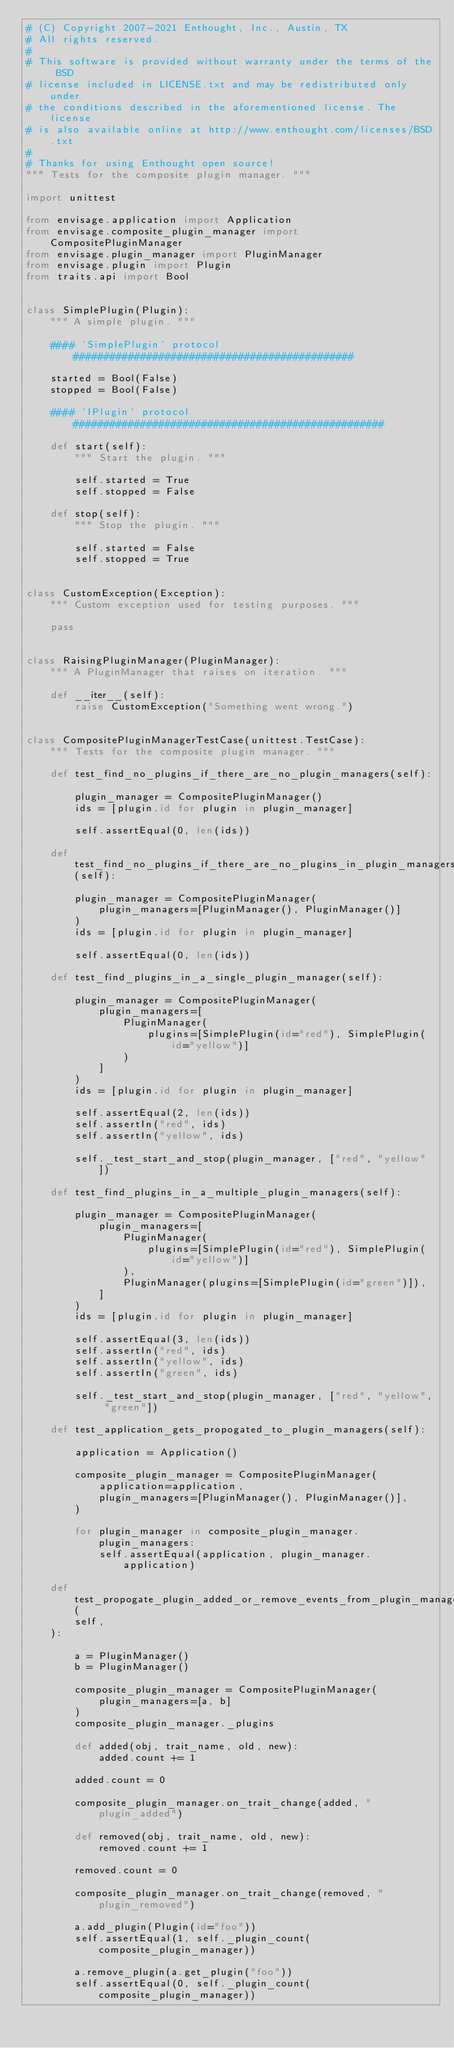<code> <loc_0><loc_0><loc_500><loc_500><_Python_># (C) Copyright 2007-2021 Enthought, Inc., Austin, TX
# All rights reserved.
#
# This software is provided without warranty under the terms of the BSD
# license included in LICENSE.txt and may be redistributed only under
# the conditions described in the aforementioned license. The license
# is also available online at http://www.enthought.com/licenses/BSD.txt
#
# Thanks for using Enthought open source!
""" Tests for the composite plugin manager. """

import unittest

from envisage.application import Application
from envisage.composite_plugin_manager import CompositePluginManager
from envisage.plugin_manager import PluginManager
from envisage.plugin import Plugin
from traits.api import Bool


class SimplePlugin(Plugin):
    """ A simple plugin. """

    #### 'SimplePlugin' protocol ##############################################

    started = Bool(False)
    stopped = Bool(False)

    #### 'IPlugin' protocol ###################################################

    def start(self):
        """ Start the plugin. """

        self.started = True
        self.stopped = False

    def stop(self):
        """ Stop the plugin. """

        self.started = False
        self.stopped = True


class CustomException(Exception):
    """ Custom exception used for testing purposes. """

    pass


class RaisingPluginManager(PluginManager):
    """ A PluginManager that raises on iteration. """

    def __iter__(self):
        raise CustomException("Something went wrong.")


class CompositePluginManagerTestCase(unittest.TestCase):
    """ Tests for the composite plugin manager. """

    def test_find_no_plugins_if_there_are_no_plugin_managers(self):

        plugin_manager = CompositePluginManager()
        ids = [plugin.id for plugin in plugin_manager]

        self.assertEqual(0, len(ids))

    def test_find_no_plugins_if_there_are_no_plugins_in_plugin_managers(self):

        plugin_manager = CompositePluginManager(
            plugin_managers=[PluginManager(), PluginManager()]
        )
        ids = [plugin.id for plugin in plugin_manager]

        self.assertEqual(0, len(ids))

    def test_find_plugins_in_a_single_plugin_manager(self):

        plugin_manager = CompositePluginManager(
            plugin_managers=[
                PluginManager(
                    plugins=[SimplePlugin(id="red"), SimplePlugin(id="yellow")]
                )
            ]
        )
        ids = [plugin.id for plugin in plugin_manager]

        self.assertEqual(2, len(ids))
        self.assertIn("red", ids)
        self.assertIn("yellow", ids)

        self._test_start_and_stop(plugin_manager, ["red", "yellow"])

    def test_find_plugins_in_a_multiple_plugin_managers(self):

        plugin_manager = CompositePluginManager(
            plugin_managers=[
                PluginManager(
                    plugins=[SimplePlugin(id="red"), SimplePlugin(id="yellow")]
                ),
                PluginManager(plugins=[SimplePlugin(id="green")]),
            ]
        )
        ids = [plugin.id for plugin in plugin_manager]

        self.assertEqual(3, len(ids))
        self.assertIn("red", ids)
        self.assertIn("yellow", ids)
        self.assertIn("green", ids)

        self._test_start_and_stop(plugin_manager, ["red", "yellow", "green"])

    def test_application_gets_propogated_to_plugin_managers(self):

        application = Application()

        composite_plugin_manager = CompositePluginManager(
            application=application,
            plugin_managers=[PluginManager(), PluginManager()],
        )

        for plugin_manager in composite_plugin_manager.plugin_managers:
            self.assertEqual(application, plugin_manager.application)

    def test_propogate_plugin_added_or_remove_events_from_plugin_managers(
        self,
    ):

        a = PluginManager()
        b = PluginManager()

        composite_plugin_manager = CompositePluginManager(
            plugin_managers=[a, b]
        )
        composite_plugin_manager._plugins

        def added(obj, trait_name, old, new):
            added.count += 1

        added.count = 0

        composite_plugin_manager.on_trait_change(added, "plugin_added")

        def removed(obj, trait_name, old, new):
            removed.count += 1

        removed.count = 0

        composite_plugin_manager.on_trait_change(removed, "plugin_removed")

        a.add_plugin(Plugin(id="foo"))
        self.assertEqual(1, self._plugin_count(composite_plugin_manager))

        a.remove_plugin(a.get_plugin("foo"))
        self.assertEqual(0, self._plugin_count(composite_plugin_manager))
</code> 